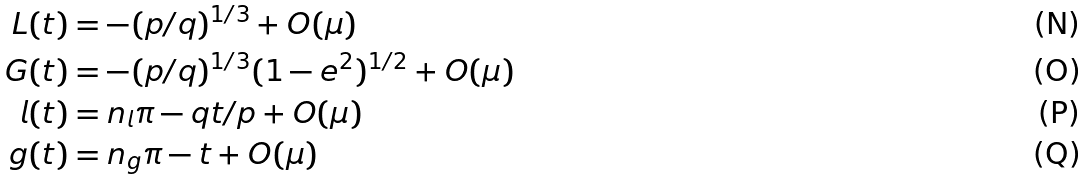Convert formula to latex. <formula><loc_0><loc_0><loc_500><loc_500>L ( t ) & = - ( p / q ) ^ { 1 / 3 } + O ( \mu ) \\ G ( t ) & = - ( p / q ) ^ { 1 / 3 } ( 1 - e ^ { 2 } ) ^ { 1 / 2 } + O ( \mu ) \\ l ( t ) & = n _ { l } \pi - q t / p + O ( \mu ) \\ g ( t ) & = n _ { g } \pi - t + O ( \mu )</formula> 